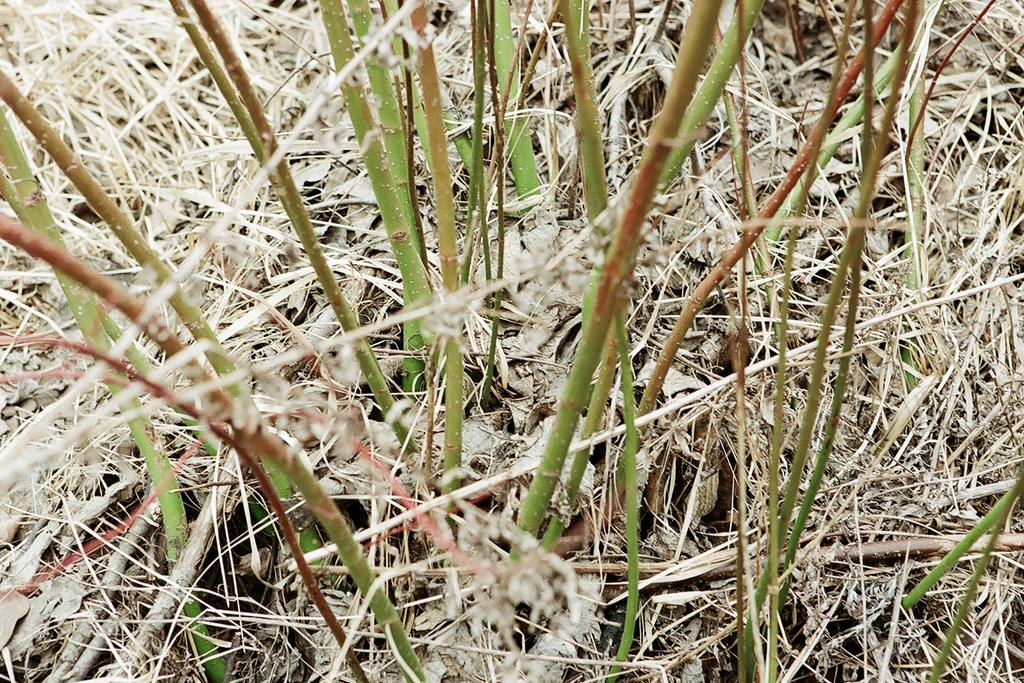What type of surface is visible in the image? There is a lawn in the image. What is covering the lawn? There is straw on the lawn. What type of vegetation can be seen in the image? There are plants in the image. How many baby animals are playing with the coat in the image? There is no coat or baby animals present in the image. 